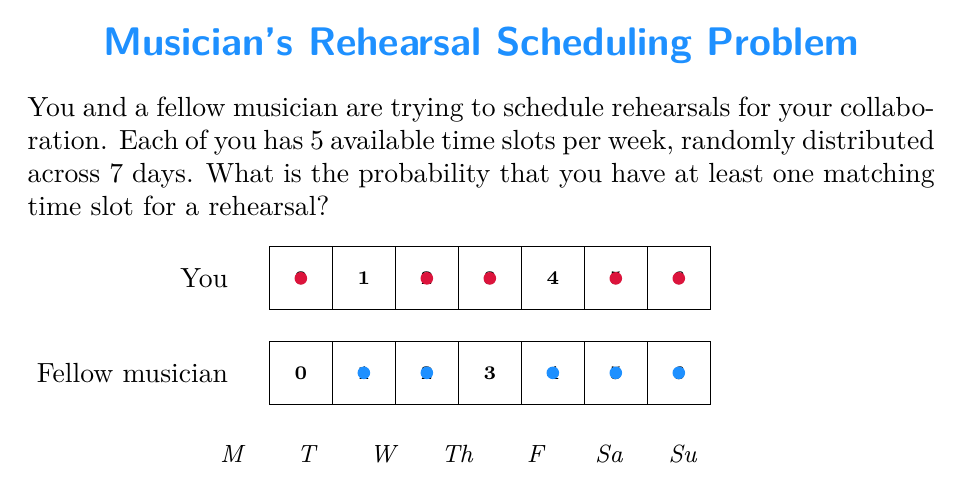Help me with this question. Let's approach this step-by-step:

1) First, we need to calculate the probability of not having a match on a single day. 
   There are $\binom{7}{1} = 7$ ways to choose a day.

2) The probability of you choosing a specific day is $\frac{5}{7}$, and the probability of not choosing it is $\frac{2}{7}$.

3) The probability of the fellow musician not choosing the same day is also $\frac{2}{7}$.

4) So, the probability of not having a match on a specific day is:

   $$P(\text{no match on a day}) = \frac{5}{7} \cdot \frac{2}{7} + \frac{2}{7} \cdot \frac{5}{7} + \frac{2}{7} \cdot \frac{2}{7} = \frac{18}{49}$$

5) For there to be no match at all, this needs to happen for all 7 days. The probability of this is:

   $$P(\text{no match at all}) = \left(\frac{18}{49}\right)^7 \approx 0.0216$$

6) Therefore, the probability of having at least one match is:

   $$P(\text{at least one match}) = 1 - P(\text{no match at all}) = 1 - \left(\frac{18}{49}\right)^7 \approx 0.9784$$

7) Converting to a percentage:

   $$0.9784 \cdot 100\% \approx 97.84\%$$
Answer: $97.84\%$ 